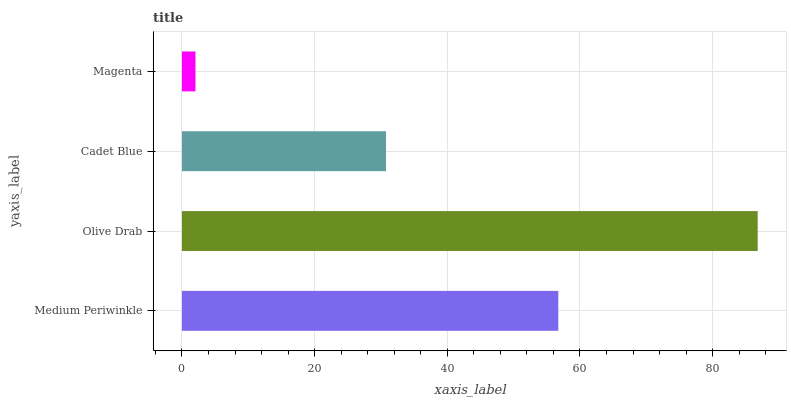Is Magenta the minimum?
Answer yes or no. Yes. Is Olive Drab the maximum?
Answer yes or no. Yes. Is Cadet Blue the minimum?
Answer yes or no. No. Is Cadet Blue the maximum?
Answer yes or no. No. Is Olive Drab greater than Cadet Blue?
Answer yes or no. Yes. Is Cadet Blue less than Olive Drab?
Answer yes or no. Yes. Is Cadet Blue greater than Olive Drab?
Answer yes or no. No. Is Olive Drab less than Cadet Blue?
Answer yes or no. No. Is Medium Periwinkle the high median?
Answer yes or no. Yes. Is Cadet Blue the low median?
Answer yes or no. Yes. Is Olive Drab the high median?
Answer yes or no. No. Is Medium Periwinkle the low median?
Answer yes or no. No. 